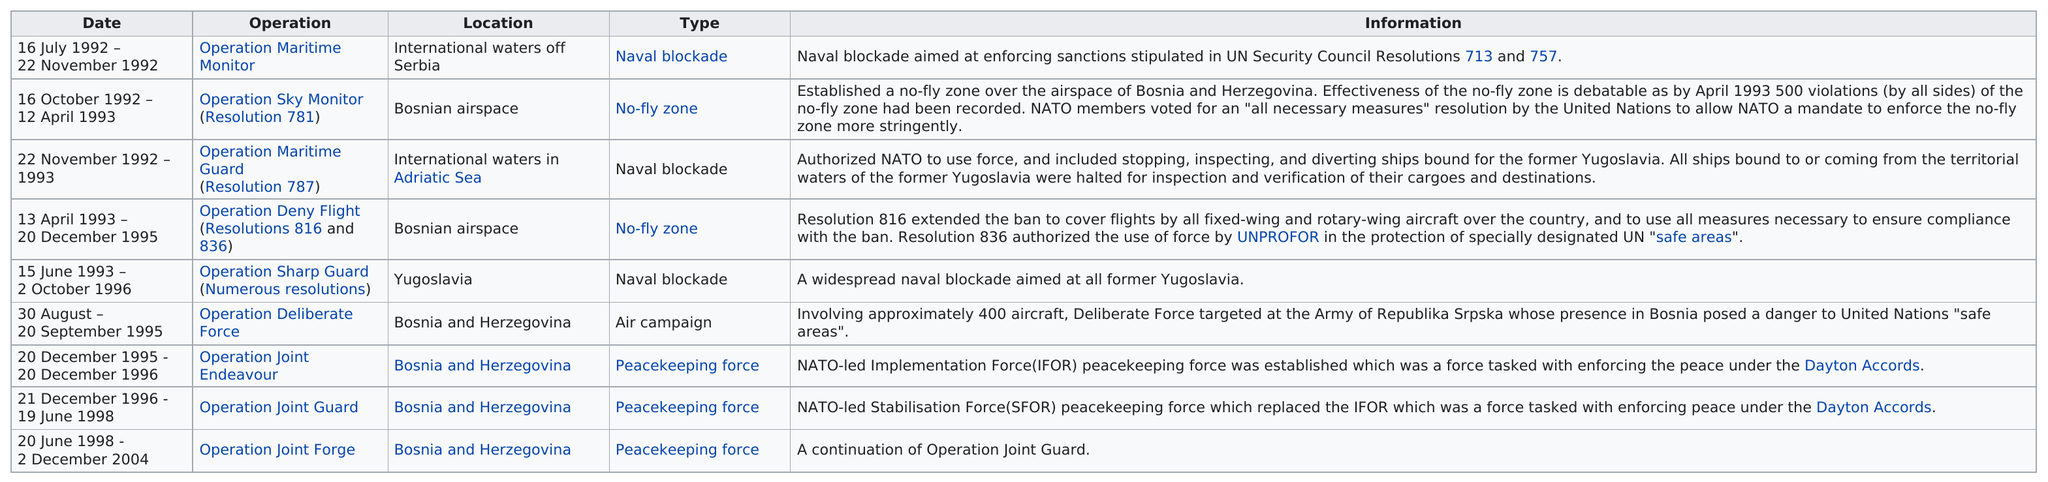Indicate a few pertinent items in this graphic. Operation Deny Flight occurred immediately after Operation Maritime Guard. What is the date after the first one on November 22, 1992? What is the total number of operations in the number sequence 9...? There have been a total of three NATO naval blockades in history. The operation known as Joint Guard is the only one that includes the joint guard. 